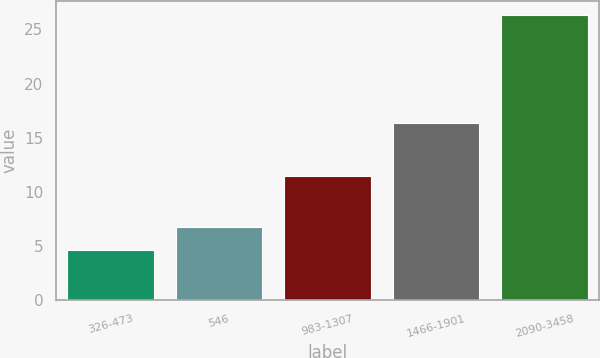Convert chart. <chart><loc_0><loc_0><loc_500><loc_500><bar_chart><fcel>326-473<fcel>546<fcel>983-1307<fcel>1466-1901<fcel>2090-3458<nl><fcel>4.64<fcel>6.81<fcel>11.49<fcel>16.38<fcel>26.31<nl></chart> 